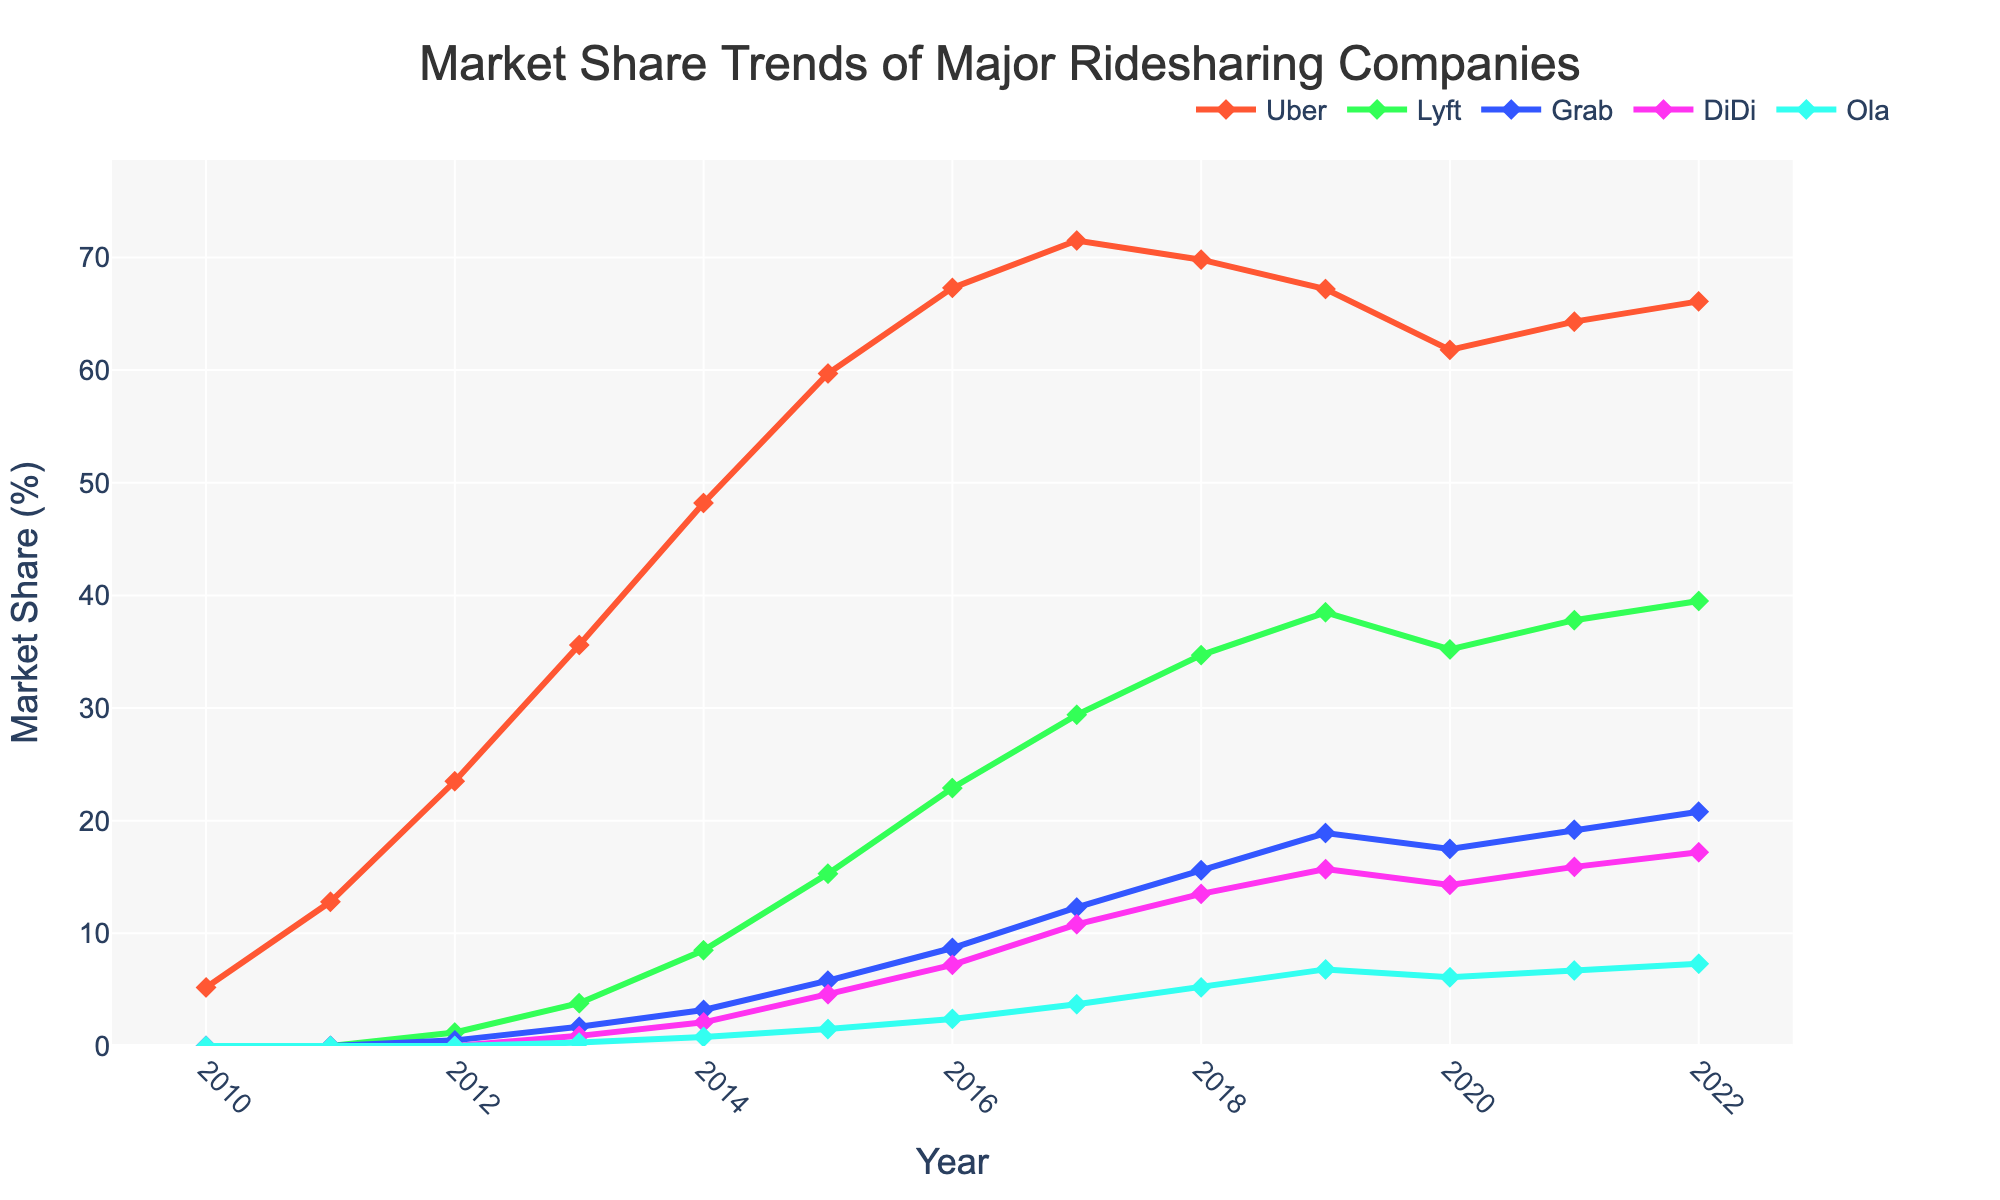Which company had the highest market share in 2016? Looking at the figure, we examine the height of the lines in 2016. Uber's line is the highest.
Answer: Uber How did Uber's market share from 2018 to 2020 compare to Lyft's during the same period? From 2018 to 2020, Uber’s share decreased from 69.8% to 61.8%, while Lyft's increased from 34.7% to 35.2%. Thus, Uber’s share decreased, and Lyft’s remained roughly the same with slight growth.
Answer: Uber’s share decreased, and Lyft's remained roughly the same Which company had the smallest market share in 2012, and what was it? Observing the figure, in 2012, Ola had the smallest market share with its line at the lowest point.
Answer: Ola, 0.5% How much did DiDi's market share increase from 2013 to 2022? DiDi’s share increased from 0.9% in 2013 to 17.2% in 2022. The difference is 17.2% - 0.9% = 16.3%.
Answer: 16.3% Between 2015 and 2017, which company showed the greatest proportional increase in market share? Calculating proportional increases: for Uber (from 59.7% to 71.5%), Lyft (from 15.3% to 29.4%), Grab (from 5.8% to 12.3%), DiDi (from 4.6% to 10.8%), and Ola (from 1.5% to 3.7%). Lyft has the greatest increase (from 15.3% to 29.4%), which is nearly double (15.3/29.4).
Answer: Lyft Which two companies had a combined market share of over 50% in 2022? Adding up the top companies' shares in 2022: Uber (66.1%) and any other company is not needed as Uber alone exceeds 50%.
Answer: Uber alone In which year did Lyft's market share first exceed 10%? Examining the figure, Lyft first exceeded 10% in 2015.
Answer: 2015 What is the difference between Uber's highest and lowest market share values in the provided time period? The highest value for Uber is 71.5% in 2017, and the lowest is 5.2% in 2010. The difference is 71.5% - 5.2% = 66.3%.
Answer: 66.3% Between 2020 and 2021, did any company other than Lyft experience an increase in market share? Observing all the lines from 2020 to 2021, Uber, Grab, DiDi, and Ola also had increases.
Answer: Yes What’s the total market share of Grab, DiDi, and Ola in 2019? Summing their shares in 2019: Grab (18.9%), DiDi (15.7%), and Ola (6.8%); total is 18.9 + 15.7 + 6.8 = 41.4%.
Answer: 41.4% 